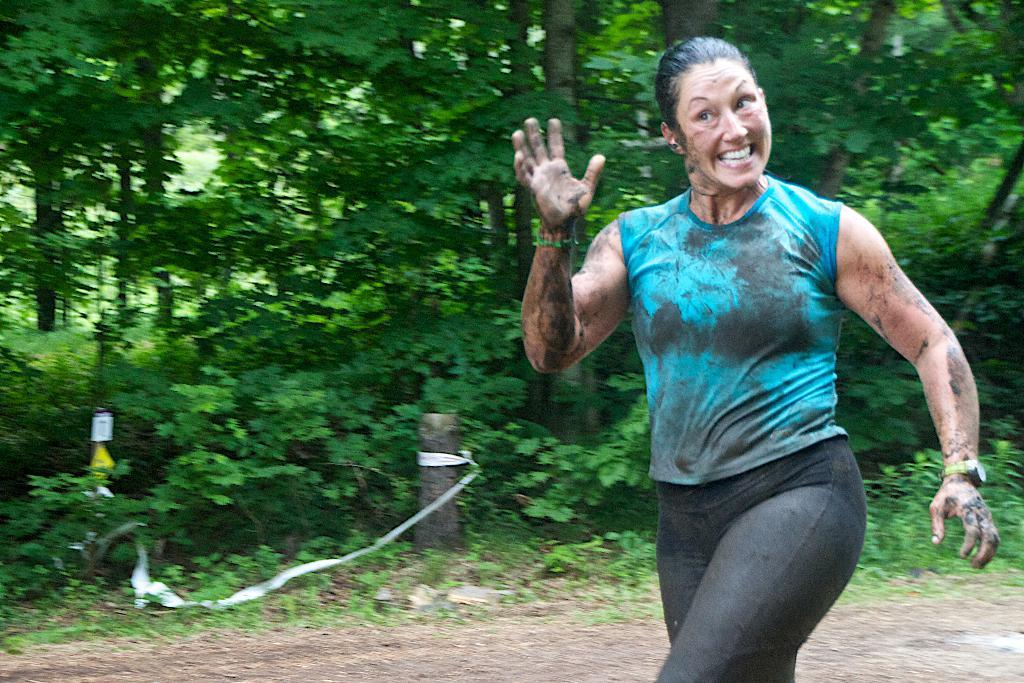Who or what is present in the image? There is a person in the image. What is the person doing or expressing? The person is smiling. What can be seen in the background of the image? There are plants and trees in the background of the image. What type of pollution can be seen in the image? There is no indication of pollution in the image. 